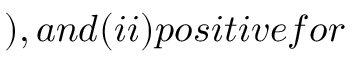<formula> <loc_0><loc_0><loc_500><loc_500>) , a n d ( i i ) p o s i t i v e f o r</formula> 